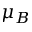Convert formula to latex. <formula><loc_0><loc_0><loc_500><loc_500>\mu _ { B }</formula> 